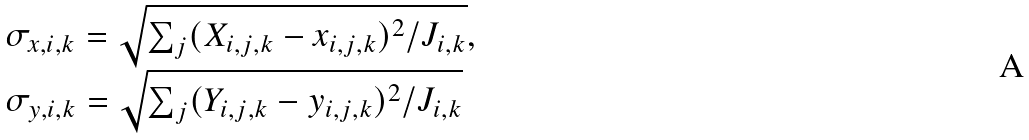Convert formula to latex. <formula><loc_0><loc_0><loc_500><loc_500>\begin{array} { l l } \sigma _ { x , i , k } = \sqrt { \sum _ { j } ( X _ { i , j , k } - x _ { i , j , k } ) ^ { 2 } / J _ { i , k } } , \\ \sigma _ { y , i , k } = \sqrt { \sum _ { j } ( Y _ { i , j , k } - y _ { i , j , k } ) ^ { 2 } / J _ { i , k } } \end{array}</formula> 